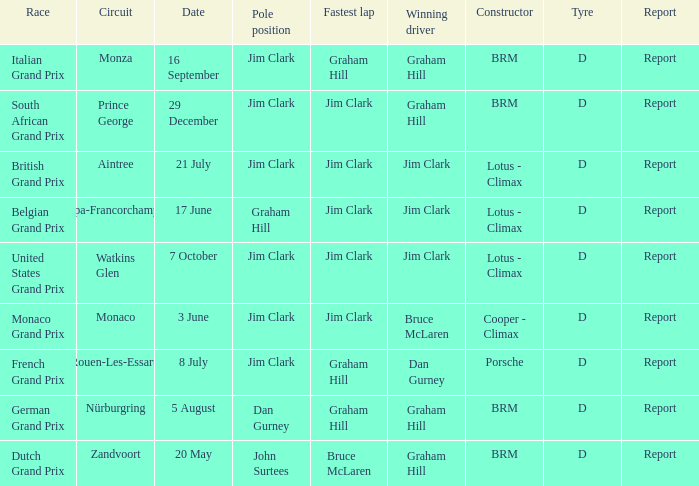What is the tyre on the race where Bruce Mclaren had the fastest lap? D. 